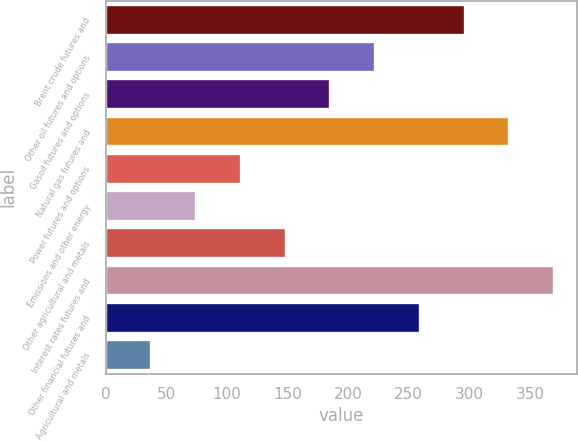Convert chart to OTSL. <chart><loc_0><loc_0><loc_500><loc_500><bar_chart><fcel>Brent crude futures and<fcel>Other oil futures and options<fcel>Gasoil futures and options<fcel>Natural gas futures and<fcel>Power futures and options<fcel>Emissions and other energy<fcel>Other agricultural and metals<fcel>Interest rates futures and<fcel>Other financial futures and<fcel>Agricultural and metals<nl><fcel>296.15<fcel>222.27<fcel>185.33<fcel>333.09<fcel>111.45<fcel>74.51<fcel>148.39<fcel>370.03<fcel>259.21<fcel>37.57<nl></chart> 